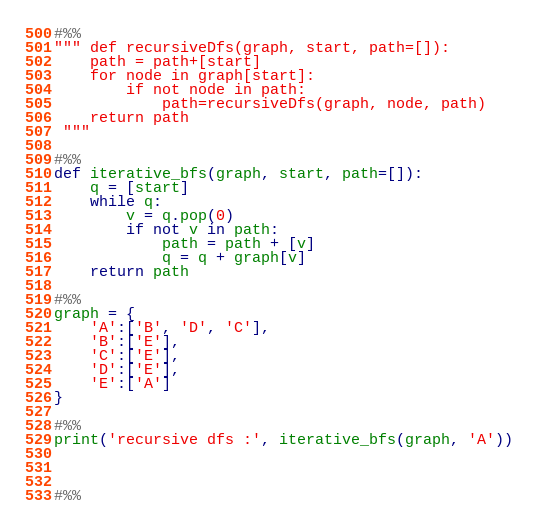Convert code to text. <code><loc_0><loc_0><loc_500><loc_500><_Python_>

#%%
""" def recursiveDfs(graph, start, path=[]):
    path = path+[start]
    for node in graph[start]:
        if not node in path:
            path=recursiveDfs(graph, node, path)
    return path
 """

#%%
def iterative_bfs(graph, start, path=[]):
    q = [start]
    while q:
        v = q.pop(0)
        if not v in path:
            path = path + [v]
            q = q + graph[v]
    return path

#%%
graph = {
    'A':['B', 'D', 'C'],
    'B':['E'],
    'C':['E'],
    'D':['E'],
    'E':['A']
}

#%%
print('recursive dfs :', iterative_bfs(graph, 'A'))



#%%
</code> 